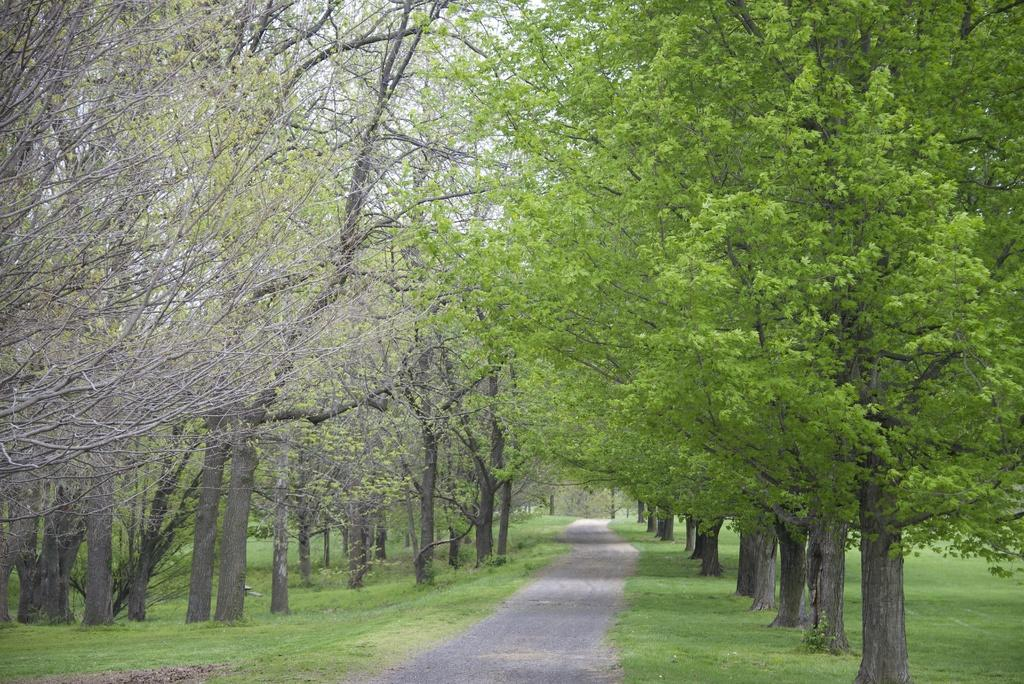What type of vegetation can be seen in the image? There are trees in the image. What is located in the middle of the image? There is a road in the middle of the image. What type of ground surface is visible in the image? There is grass on the ground in the image. Is the road covered in dust in the image? There is no mention of dust in the image, so we cannot determine if the road is covered in dust. Can you tell me how deep the quicksand is in the image? There is no quicksand present in the image. 